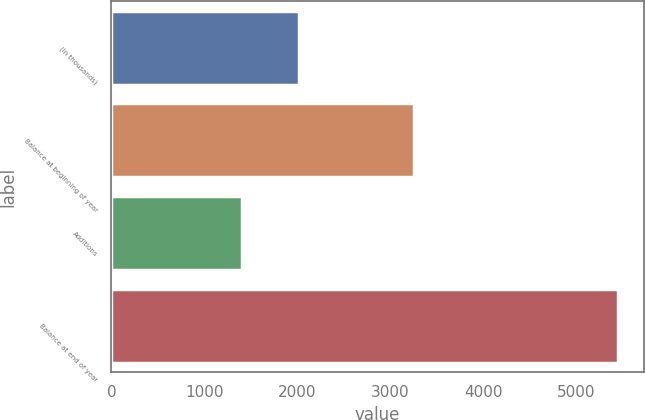<chart> <loc_0><loc_0><loc_500><loc_500><bar_chart><fcel>(In thousands)<fcel>Balance at beginning of year<fcel>Additions<fcel>Balance at end of year<nl><fcel>2015<fcel>3255<fcel>1407<fcel>5448<nl></chart> 